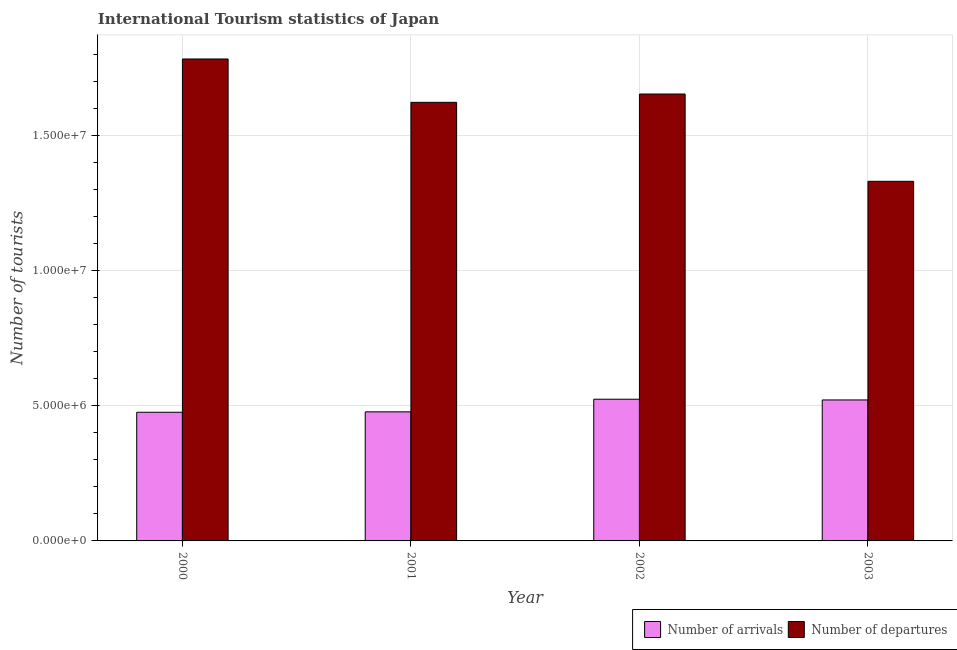How many different coloured bars are there?
Ensure brevity in your answer.  2. How many groups of bars are there?
Provide a succinct answer. 4. How many bars are there on the 4th tick from the left?
Your answer should be very brief. 2. How many bars are there on the 4th tick from the right?
Give a very brief answer. 2. What is the label of the 3rd group of bars from the left?
Your answer should be very brief. 2002. What is the number of tourist arrivals in 2003?
Your response must be concise. 5.21e+06. Across all years, what is the maximum number of tourist departures?
Offer a terse response. 1.78e+07. Across all years, what is the minimum number of tourist departures?
Your answer should be compact. 1.33e+07. In which year was the number of tourist departures minimum?
Offer a terse response. 2003. What is the total number of tourist departures in the graph?
Ensure brevity in your answer.  6.39e+07. What is the difference between the number of tourist departures in 2002 and that in 2003?
Provide a succinct answer. 3.23e+06. What is the difference between the number of tourist arrivals in 2001 and the number of tourist departures in 2002?
Keep it short and to the point. -4.67e+05. What is the average number of tourist departures per year?
Your answer should be very brief. 1.60e+07. What is the ratio of the number of tourist arrivals in 2000 to that in 2002?
Give a very brief answer. 0.91. Is the number of tourist arrivals in 2000 less than that in 2002?
Provide a short and direct response. Yes. What is the difference between the highest and the second highest number of tourist departures?
Your answer should be compact. 1.30e+06. What is the difference between the highest and the lowest number of tourist departures?
Provide a succinct answer. 4.52e+06. In how many years, is the number of tourist departures greater than the average number of tourist departures taken over all years?
Provide a succinct answer. 3. What does the 2nd bar from the left in 2003 represents?
Offer a terse response. Number of departures. What does the 2nd bar from the right in 2000 represents?
Your response must be concise. Number of arrivals. How many bars are there?
Offer a terse response. 8. Are all the bars in the graph horizontal?
Provide a short and direct response. No. What is the difference between two consecutive major ticks on the Y-axis?
Make the answer very short. 5.00e+06. Are the values on the major ticks of Y-axis written in scientific E-notation?
Offer a very short reply. Yes. Does the graph contain any zero values?
Offer a very short reply. No. Does the graph contain grids?
Give a very brief answer. Yes. Where does the legend appear in the graph?
Ensure brevity in your answer.  Bottom right. How many legend labels are there?
Ensure brevity in your answer.  2. How are the legend labels stacked?
Offer a terse response. Horizontal. What is the title of the graph?
Offer a very short reply. International Tourism statistics of Japan. What is the label or title of the Y-axis?
Give a very brief answer. Number of tourists. What is the Number of tourists in Number of arrivals in 2000?
Your answer should be compact. 4.76e+06. What is the Number of tourists in Number of departures in 2000?
Ensure brevity in your answer.  1.78e+07. What is the Number of tourists in Number of arrivals in 2001?
Give a very brief answer. 4.77e+06. What is the Number of tourists of Number of departures in 2001?
Your answer should be very brief. 1.62e+07. What is the Number of tourists in Number of arrivals in 2002?
Offer a terse response. 5.24e+06. What is the Number of tourists of Number of departures in 2002?
Make the answer very short. 1.65e+07. What is the Number of tourists of Number of arrivals in 2003?
Your answer should be compact. 5.21e+06. What is the Number of tourists in Number of departures in 2003?
Make the answer very short. 1.33e+07. Across all years, what is the maximum Number of tourists in Number of arrivals?
Make the answer very short. 5.24e+06. Across all years, what is the maximum Number of tourists in Number of departures?
Offer a very short reply. 1.78e+07. Across all years, what is the minimum Number of tourists in Number of arrivals?
Give a very brief answer. 4.76e+06. Across all years, what is the minimum Number of tourists in Number of departures?
Your answer should be very brief. 1.33e+07. What is the total Number of tourists in Number of arrivals in the graph?
Ensure brevity in your answer.  2.00e+07. What is the total Number of tourists in Number of departures in the graph?
Offer a terse response. 6.39e+07. What is the difference between the Number of tourists in Number of arrivals in 2000 and that in 2001?
Provide a short and direct response. -1.50e+04. What is the difference between the Number of tourists of Number of departures in 2000 and that in 2001?
Make the answer very short. 1.60e+06. What is the difference between the Number of tourists in Number of arrivals in 2000 and that in 2002?
Your response must be concise. -4.82e+05. What is the difference between the Number of tourists in Number of departures in 2000 and that in 2002?
Your answer should be very brief. 1.30e+06. What is the difference between the Number of tourists in Number of arrivals in 2000 and that in 2003?
Your answer should be very brief. -4.55e+05. What is the difference between the Number of tourists of Number of departures in 2000 and that in 2003?
Provide a short and direct response. 4.52e+06. What is the difference between the Number of tourists in Number of arrivals in 2001 and that in 2002?
Offer a very short reply. -4.67e+05. What is the difference between the Number of tourists of Number of departures in 2001 and that in 2002?
Make the answer very short. -3.07e+05. What is the difference between the Number of tourists of Number of arrivals in 2001 and that in 2003?
Provide a succinct answer. -4.40e+05. What is the difference between the Number of tourists in Number of departures in 2001 and that in 2003?
Provide a short and direct response. 2.92e+06. What is the difference between the Number of tourists of Number of arrivals in 2002 and that in 2003?
Provide a short and direct response. 2.70e+04. What is the difference between the Number of tourists in Number of departures in 2002 and that in 2003?
Provide a succinct answer. 3.23e+06. What is the difference between the Number of tourists of Number of arrivals in 2000 and the Number of tourists of Number of departures in 2001?
Offer a very short reply. -1.15e+07. What is the difference between the Number of tourists in Number of arrivals in 2000 and the Number of tourists in Number of departures in 2002?
Your answer should be very brief. -1.18e+07. What is the difference between the Number of tourists of Number of arrivals in 2000 and the Number of tourists of Number of departures in 2003?
Provide a succinct answer. -8.54e+06. What is the difference between the Number of tourists in Number of arrivals in 2001 and the Number of tourists in Number of departures in 2002?
Your answer should be compact. -1.18e+07. What is the difference between the Number of tourists in Number of arrivals in 2001 and the Number of tourists in Number of departures in 2003?
Provide a short and direct response. -8.52e+06. What is the difference between the Number of tourists of Number of arrivals in 2002 and the Number of tourists of Number of departures in 2003?
Give a very brief answer. -8.06e+06. What is the average Number of tourists in Number of arrivals per year?
Your response must be concise. 5.00e+06. What is the average Number of tourists in Number of departures per year?
Provide a short and direct response. 1.60e+07. In the year 2000, what is the difference between the Number of tourists of Number of arrivals and Number of tourists of Number of departures?
Offer a very short reply. -1.31e+07. In the year 2001, what is the difference between the Number of tourists of Number of arrivals and Number of tourists of Number of departures?
Make the answer very short. -1.14e+07. In the year 2002, what is the difference between the Number of tourists of Number of arrivals and Number of tourists of Number of departures?
Keep it short and to the point. -1.13e+07. In the year 2003, what is the difference between the Number of tourists in Number of arrivals and Number of tourists in Number of departures?
Offer a terse response. -8.08e+06. What is the ratio of the Number of tourists in Number of departures in 2000 to that in 2001?
Give a very brief answer. 1.1. What is the ratio of the Number of tourists in Number of arrivals in 2000 to that in 2002?
Offer a very short reply. 0.91. What is the ratio of the Number of tourists in Number of departures in 2000 to that in 2002?
Make the answer very short. 1.08. What is the ratio of the Number of tourists of Number of arrivals in 2000 to that in 2003?
Ensure brevity in your answer.  0.91. What is the ratio of the Number of tourists in Number of departures in 2000 to that in 2003?
Keep it short and to the point. 1.34. What is the ratio of the Number of tourists in Number of arrivals in 2001 to that in 2002?
Your answer should be compact. 0.91. What is the ratio of the Number of tourists of Number of departures in 2001 to that in 2002?
Your answer should be compact. 0.98. What is the ratio of the Number of tourists of Number of arrivals in 2001 to that in 2003?
Ensure brevity in your answer.  0.92. What is the ratio of the Number of tourists in Number of departures in 2001 to that in 2003?
Keep it short and to the point. 1.22. What is the ratio of the Number of tourists of Number of departures in 2002 to that in 2003?
Keep it short and to the point. 1.24. What is the difference between the highest and the second highest Number of tourists of Number of arrivals?
Give a very brief answer. 2.70e+04. What is the difference between the highest and the second highest Number of tourists of Number of departures?
Provide a short and direct response. 1.30e+06. What is the difference between the highest and the lowest Number of tourists in Number of arrivals?
Give a very brief answer. 4.82e+05. What is the difference between the highest and the lowest Number of tourists in Number of departures?
Offer a very short reply. 4.52e+06. 